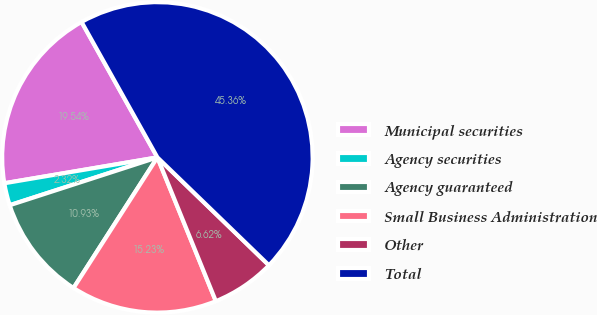<chart> <loc_0><loc_0><loc_500><loc_500><pie_chart><fcel>Municipal securities<fcel>Agency securities<fcel>Agency guaranteed<fcel>Small Business Administration<fcel>Other<fcel>Total<nl><fcel>19.54%<fcel>2.32%<fcel>10.93%<fcel>15.23%<fcel>6.62%<fcel>45.36%<nl></chart> 